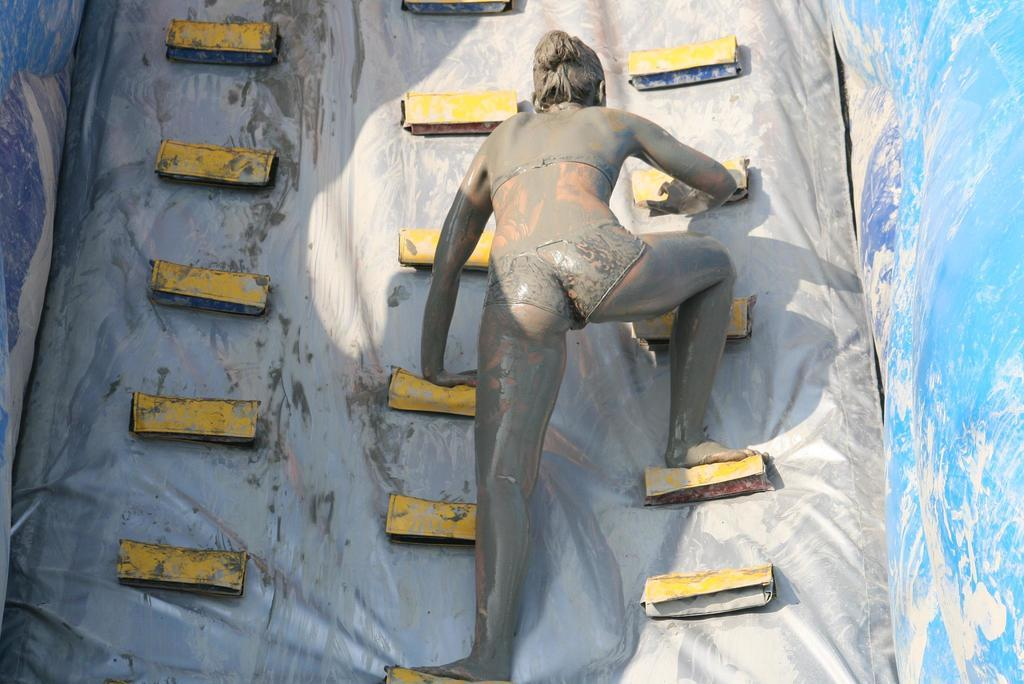Who is the main subject in the image? There is a woman in the image. What is the woman doing in the image? The woman is playing a climbing game. What type of laborer is depicted in the image? There is no laborer present in the image; it features a woman playing a climbing game. What kind of butter can be seen on the goat in the image? There is no goat or butter present in the image. 